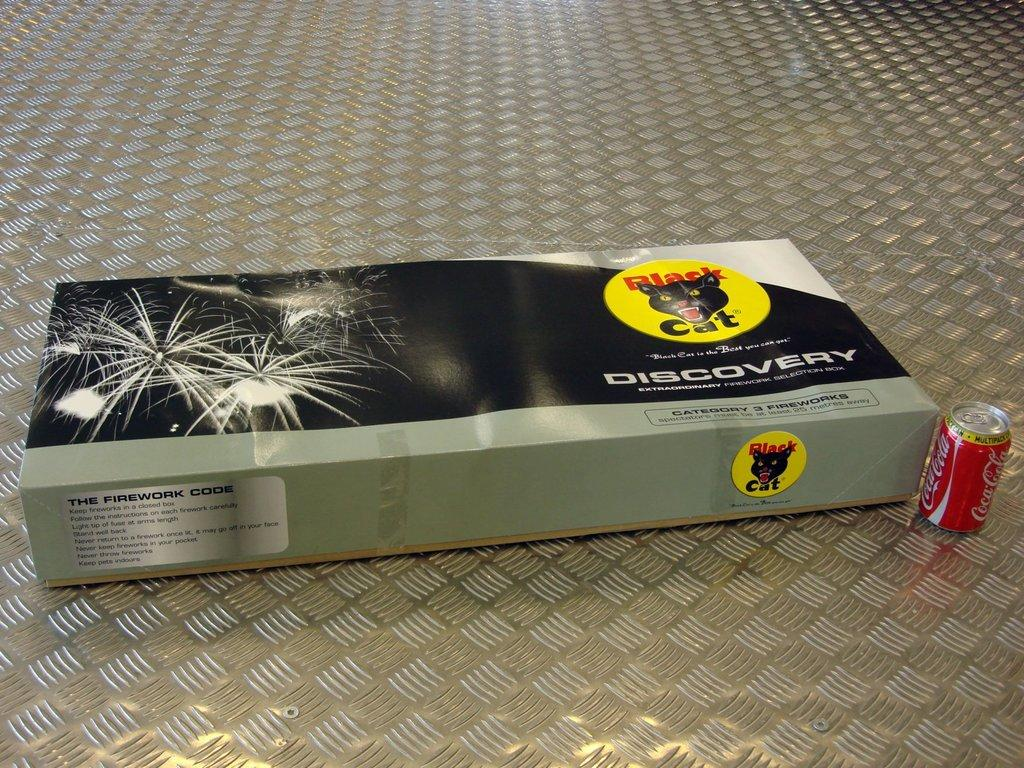<image>
Offer a succinct explanation of the picture presented. Red Coca Cola can placed in front of a box of Black Cat fireworks. 